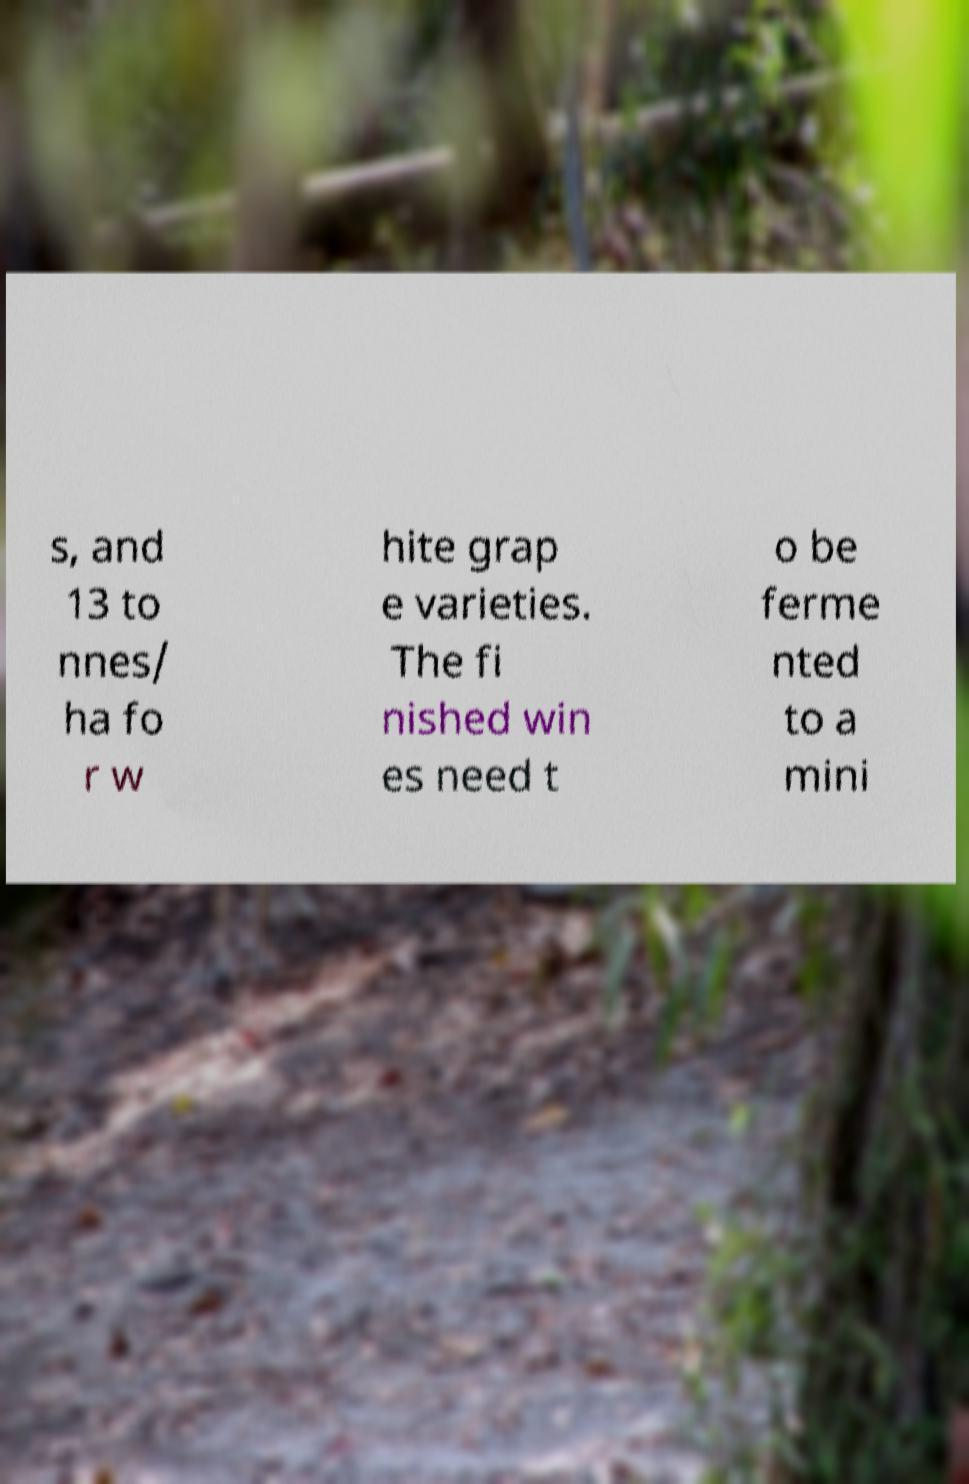What does the process of fermenting wines typically involve? Fermentation is a crucial step in winemaking where yeast converts the sugars in grape juice into alcohol and carbon dioxide. This process can vary in duration and conditions, depending on the desired style of wine being produced. Typically, it involves monitoring and controlling temperature to ensure optimal yeast activity and flavor development. 